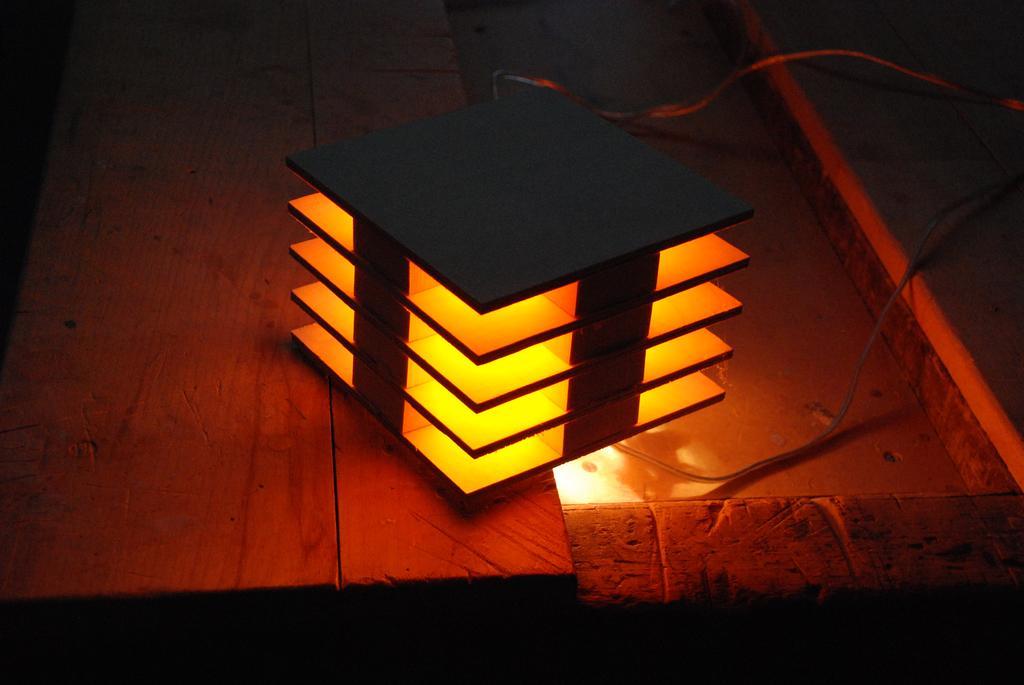Describe this image in one or two sentences. In this image I can see an object in the center of the image and I can see an orange colored light inside the object. I can see few wires and the wooden surface. 